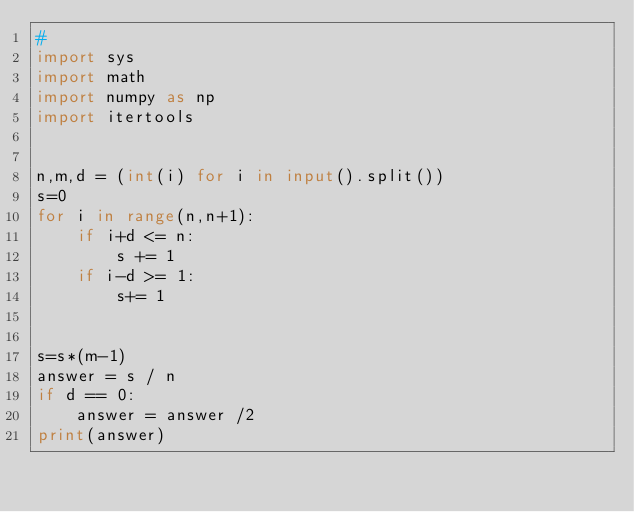Convert code to text. <code><loc_0><loc_0><loc_500><loc_500><_Python_>#
import sys
import math
import numpy as np
import itertools


n,m,d = (int(i) for i in input().split())  
s=0
for i in range(n,n+1):
    if i+d <= n:
        s += 1
    if i-d >= 1:
        s+= 1    


s=s*(m-1)
answer = s / n
if d == 0:
    answer = answer /2 
print(answer)
</code> 